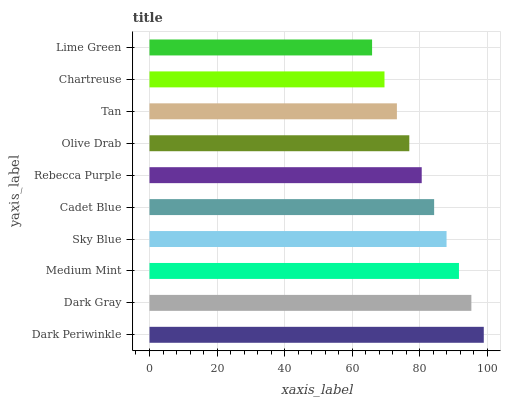Is Lime Green the minimum?
Answer yes or no. Yes. Is Dark Periwinkle the maximum?
Answer yes or no. Yes. Is Dark Gray the minimum?
Answer yes or no. No. Is Dark Gray the maximum?
Answer yes or no. No. Is Dark Periwinkle greater than Dark Gray?
Answer yes or no. Yes. Is Dark Gray less than Dark Periwinkle?
Answer yes or no. Yes. Is Dark Gray greater than Dark Periwinkle?
Answer yes or no. No. Is Dark Periwinkle less than Dark Gray?
Answer yes or no. No. Is Cadet Blue the high median?
Answer yes or no. Yes. Is Rebecca Purple the low median?
Answer yes or no. Yes. Is Sky Blue the high median?
Answer yes or no. No. Is Sky Blue the low median?
Answer yes or no. No. 